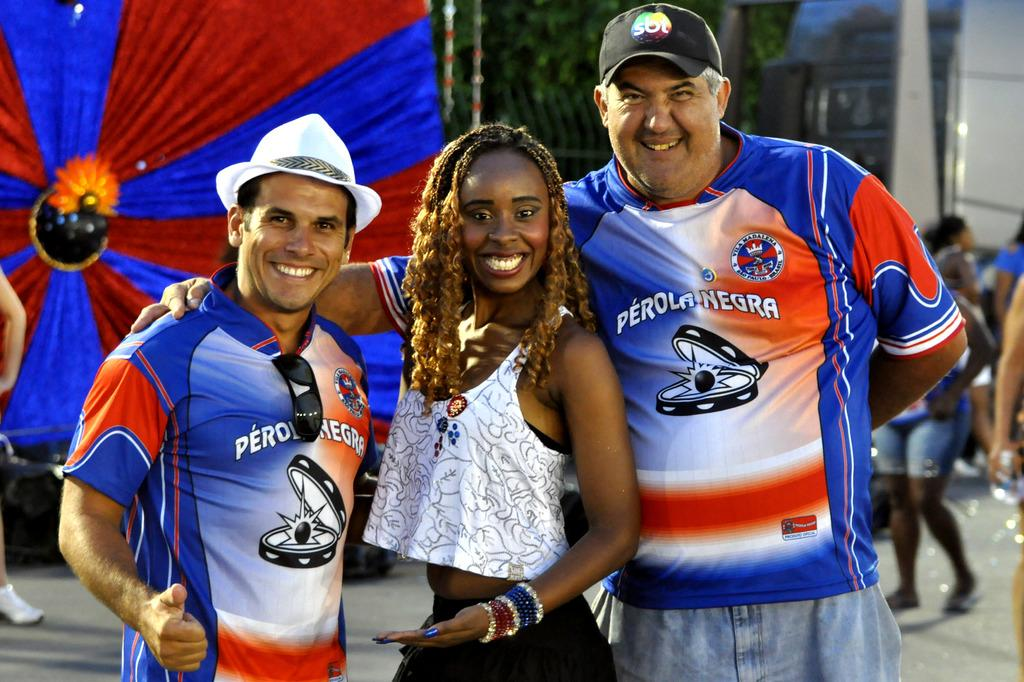<image>
Create a compact narrative representing the image presented. Three people posing for a photo with one person wearing a shirt that says "Perola Negra". 